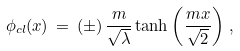<formula> <loc_0><loc_0><loc_500><loc_500>\phi _ { c l } ( x ) \, = \, ( \pm ) \, \frac { m } { \sqrt { \lambda } } \tanh \left ( \frac { m x } { \sqrt { 2 } } \right ) \, ,</formula> 